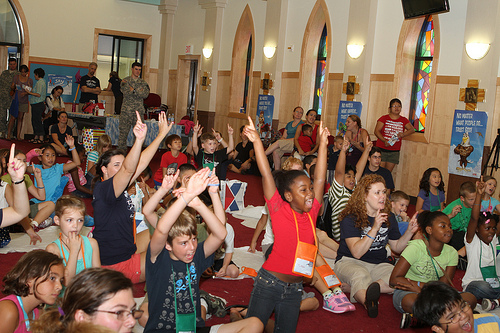<image>
Is the woman behind the girl? Yes. From this viewpoint, the woman is positioned behind the girl, with the girl partially or fully occluding the woman. 